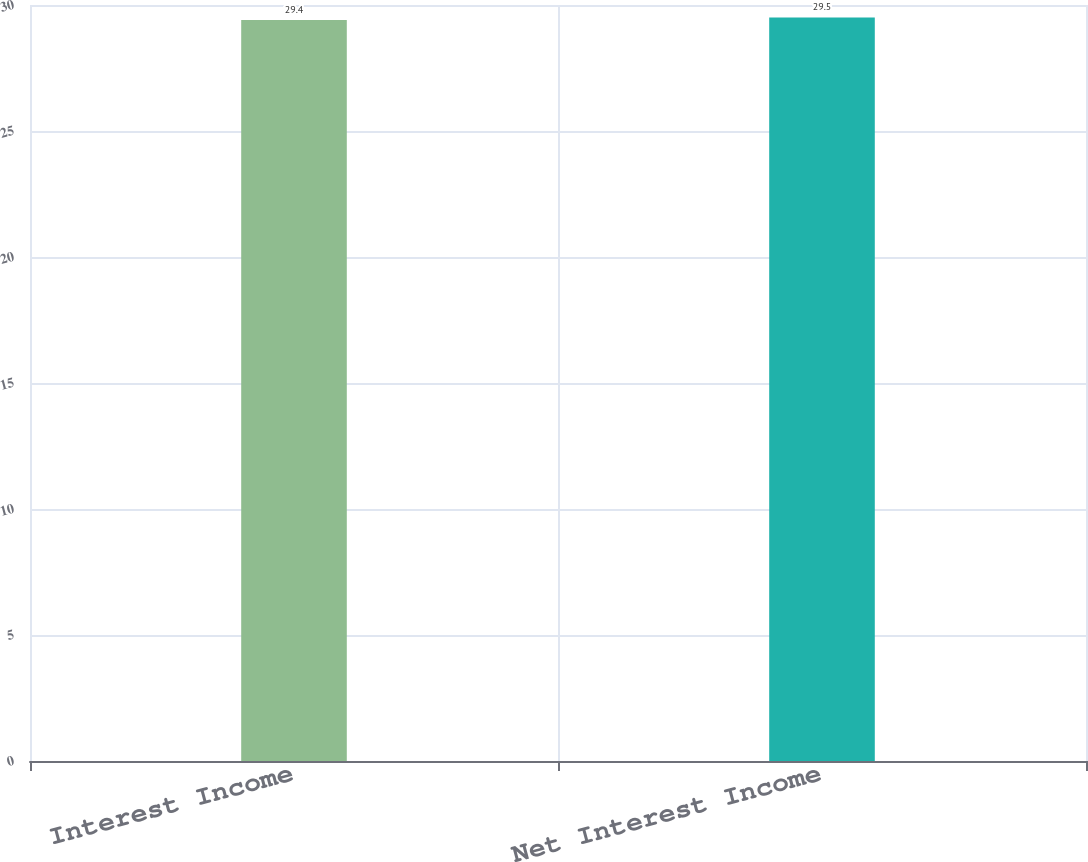Convert chart to OTSL. <chart><loc_0><loc_0><loc_500><loc_500><bar_chart><fcel>Interest Income<fcel>Net Interest Income<nl><fcel>29.4<fcel>29.5<nl></chart> 